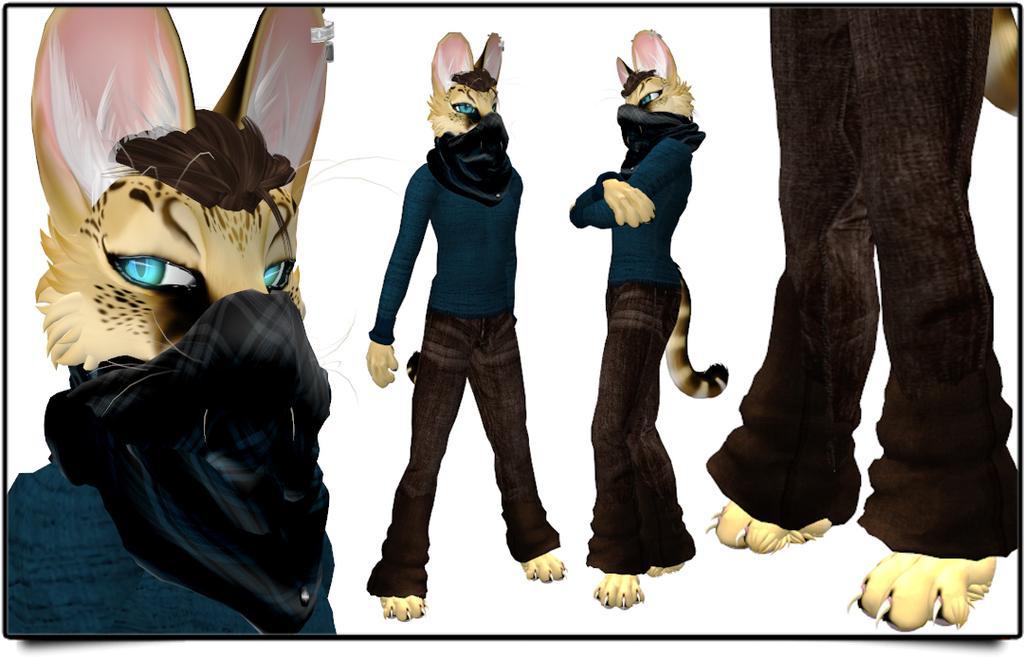Describe this image in one or two sentences. This is an animation in this image there are some animals who are wearing clothes, and there is a white background. 